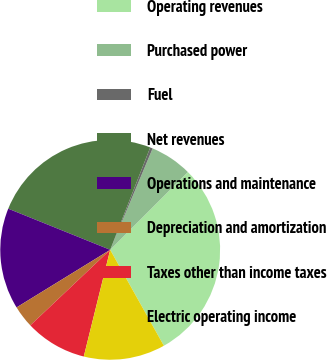Convert chart. <chart><loc_0><loc_0><loc_500><loc_500><pie_chart><fcel>Operating revenues<fcel>Purchased power<fcel>Fuel<fcel>Net revenues<fcel>Operations and maintenance<fcel>Depreciation and amortization<fcel>Taxes other than income taxes<fcel>Electric operating income<nl><fcel>29.39%<fcel>6.18%<fcel>0.38%<fcel>24.83%<fcel>14.88%<fcel>3.28%<fcel>9.08%<fcel>11.98%<nl></chart> 